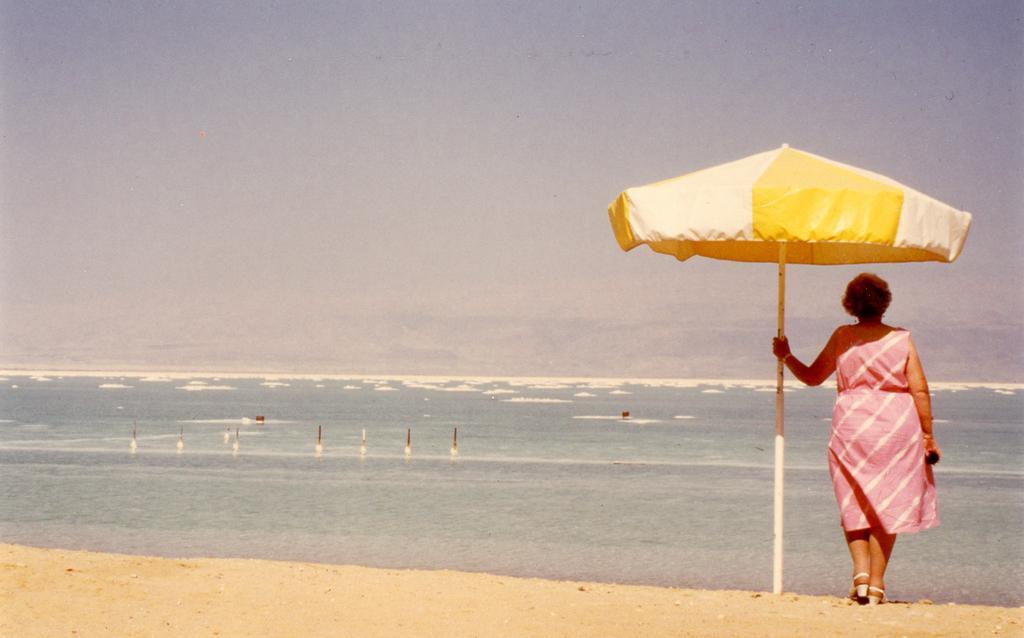Can you describe this image briefly? In the image we can see a woman standing, wearing clothes, sandals and she is holding the pole. Here we can see an umbrella, sand, water and the sky. 